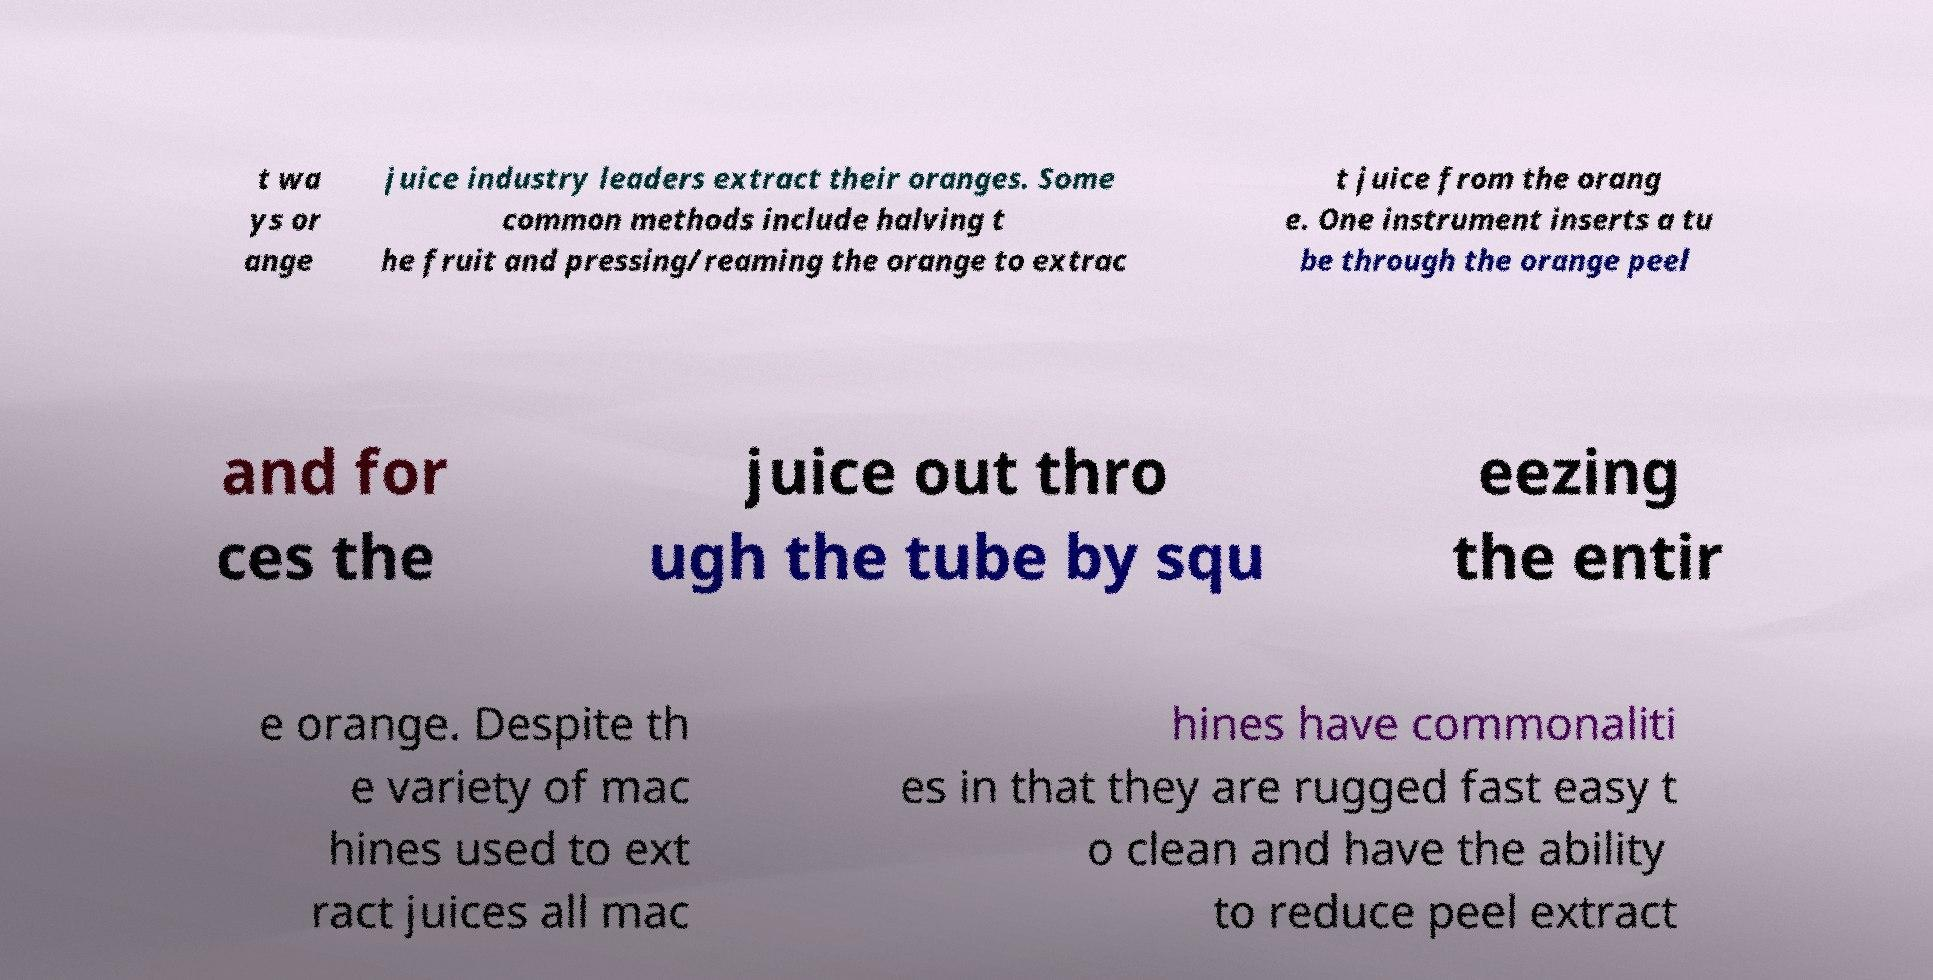Please identify and transcribe the text found in this image. t wa ys or ange juice industry leaders extract their oranges. Some common methods include halving t he fruit and pressing/reaming the orange to extrac t juice from the orang e. One instrument inserts a tu be through the orange peel and for ces the juice out thro ugh the tube by squ eezing the entir e orange. Despite th e variety of mac hines used to ext ract juices all mac hines have commonaliti es in that they are rugged fast easy t o clean and have the ability to reduce peel extract 